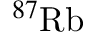Convert formula to latex. <formula><loc_0><loc_0><loc_500><loc_500>^ { 8 7 } R b</formula> 